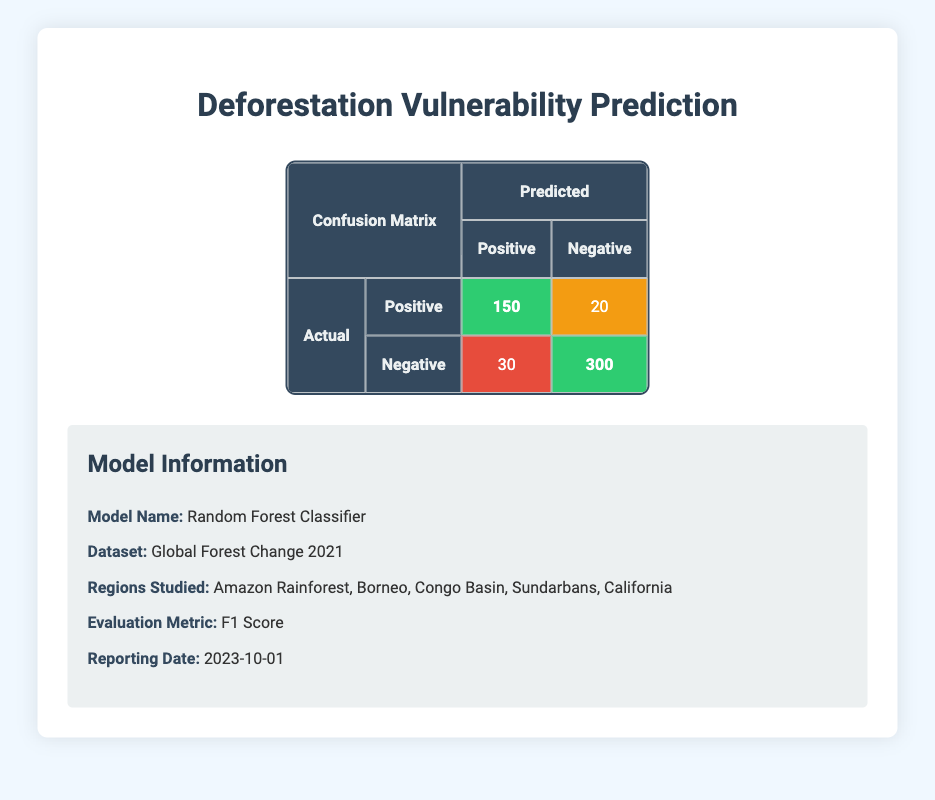What is the number of true positives according to the confusion matrix? The true positives are found in the cell where actual positive and predicted positive intersect. In the table, this value is 150.
Answer: 150 What is the number of false negatives? The false negatives are located in the cell where actual positive and predicted negative intersect. This value is 20 in the table.
Answer: 20 What is the sum of true positives and false positives? The true positives are 150, and the false positives are 30. Adding these together gives 150 + 30 = 180.
Answer: 180 Is the number of false positives greater than the number of true positives? The number of false positives is 30, which is less than the number of true positives, which is 150. Therefore, the statement is false.
Answer: No How many actual negatives were classified correctly? The number of actual negatives classified correctly corresponds to the true negatives, which is found in the cell where actual negative and predicted negative intersect. According to the table, this value is 300.
Answer: 300 What is the total number of instances classified as positive? The total number classified as positive is the sum of true positives and false positives, calculated as 150 + 30 = 180.
Answer: 180 What is the total count of actual positive instances in the confusion matrix? The total count of actual positive instances is found by adding the true positives and false negatives together. This can be seen as 150 + 20 = 170.
Answer: 170 How many instances were predicted as negative but were actually positive? This value is known as false negatives, represented by 20 in the confusion matrix.
Answer: 20 Is the F1 Score mentioned in the metadata section relevant to the confusion matrix? Yes, the F1 Score is relevant as it is a metric used to evaluate a model's performance, particularly considering both precision and recall which are derived from the values in the confusion matrix.
Answer: Yes 